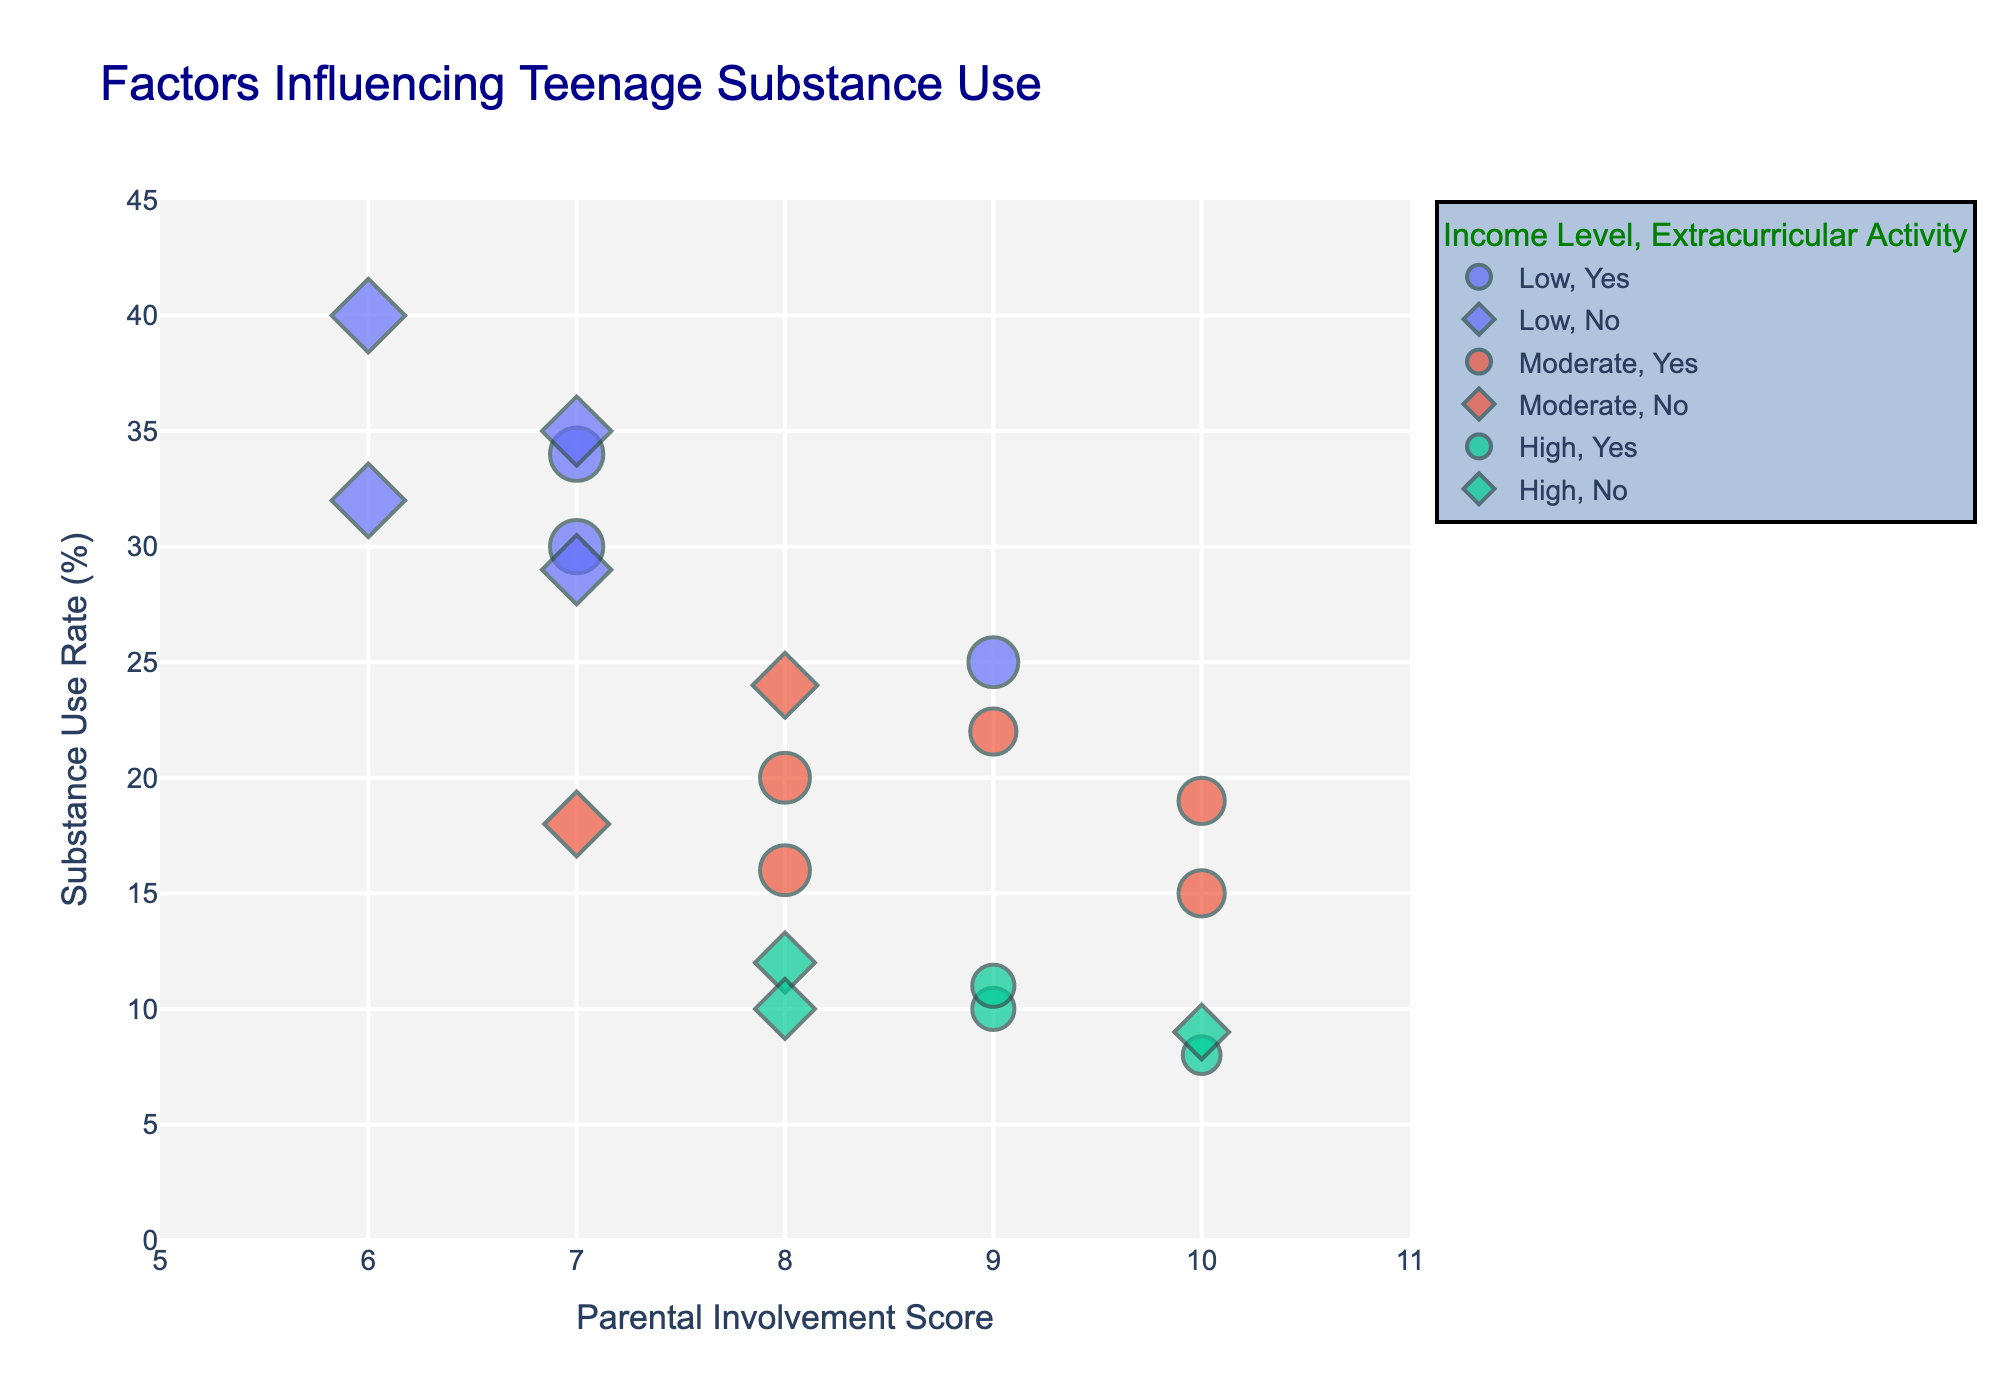How many teenagers are in the Low income group? Count the number of data points associated with the "Low" income level.
Answer: 6 Which income group has the lowest average substance use rate? Calculate the average substance use rate for each income group and compare. For Low: (25+35+40+30+32+34)/6 = 32.67, for Moderate: (15+20+18+22+16+19+24)/7 = 19.14, and for High: (10+12+8+9+11+10) / 6 = 10
Answer: High income group Is there a visible trend between mental health score and substance use rate? Look at the data points' sizes, which represent mental health scores, and their corresponding positions on the y-axis (substance use rate). Larger sizes (higher mental health scores) tend to appear at higher y-values more prominently in the Low income group.
Answer: Yes How does extracurricular activity correlate with substance use among teenagers? Compare the symbols for "Yes" and "No" in the plot, and check their distribution along the y-axis (substance use rate). Teenagers engaged in extracurricular activities tend to have lower substance use rates than those not involved.
Answer: Lower substance use rates are observed among those engaged in extracurricular activities What is the relationship between parental involvement and substance use rates? Observe the overall trend in the plot by looking at the x-axis (parental involvement) and y-axis (substance use rate). Higher parental involvement scores generally correspond to lower substance use rates.
Answer: Higher parental involvement is associated with lower substance use rates Which group shows a higher substance use rate if their friends also use substances: low or moderate income? Compare data points where "Peer_Substance_Use" is "Yes" for Low and Moderate income groups. For Low: 35, 40, 30, 32, 29, 34; for Moderate: 20, 24. Low has a higher rate.
Answer: Low income group On average, do teenagers with high parental involvement scores (8-10) have lower substance use rates compared to those with low scores (6-7)? Calculate the average substance use rates for both groups: High Parental Involvement (8-10): (15+10+9+8+22+9+11+10+19)=113/9=12.56; Low Parental Involvement (6-7): (35+40+32+29+34+20)=190/6=31.67. Yes, teenagers with higher parental involvement scores have lower substance use rates.
Answer: Yes Are teenagers from High-income households who engage in extracurricular activities less likely to use substances compared to those from the same income group who do not engage in extracurricular activities? Compare the substance use rates for High-income teenagers who are involved in extracurricular activities (10, 8, 11, 8) to those who are not (12, 9, 10). The average for involved (10+8+11+8) = 37/4 = 9.25, not involved (12+9+10) = 31/3 = 10.33. Yes, those involved have a slightly lower rate.
Answer: Yes Does higher mental health score tend to correspond to higher substance use rates in the Low-income group? Evaluate data points in the Low income group and compare mental health scores and substance use rates. Low-income teenagers with higher mental health scores (8,9) seem to have higher substance use rates (35, 40, 30, 32, 29, 34).
Answer: Yes 